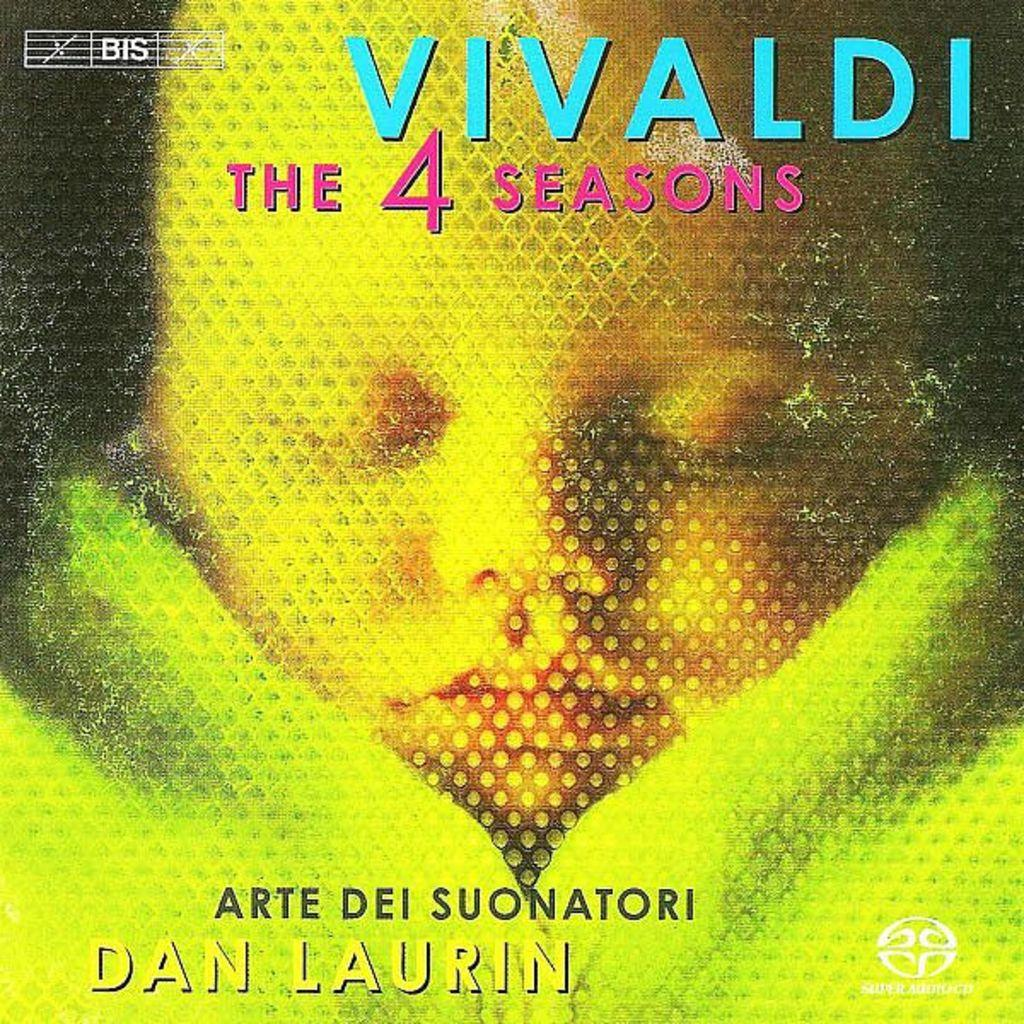<image>
Write a terse but informative summary of the picture. BIS Records released a version of the Vivaldi work entitled The Four Seasons. 